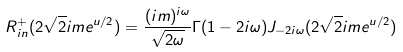<formula> <loc_0><loc_0><loc_500><loc_500>R _ { i n } ^ { + } ( 2 \sqrt { 2 } i m e ^ { u / 2 } ) = \frac { ( i m ) ^ { i \omega } } { \sqrt { 2 \omega } } \Gamma ( 1 - 2 i \omega ) J _ { - 2 i \omega } ( 2 \sqrt { 2 } i m e ^ { u / 2 } )</formula> 